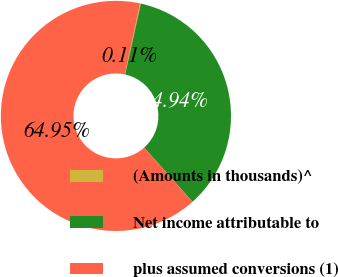Convert chart. <chart><loc_0><loc_0><loc_500><loc_500><pie_chart><fcel>(Amounts in thousands)^<fcel>Net income attributable to<fcel>plus assumed conversions (1)<nl><fcel>0.11%<fcel>34.94%<fcel>64.95%<nl></chart> 